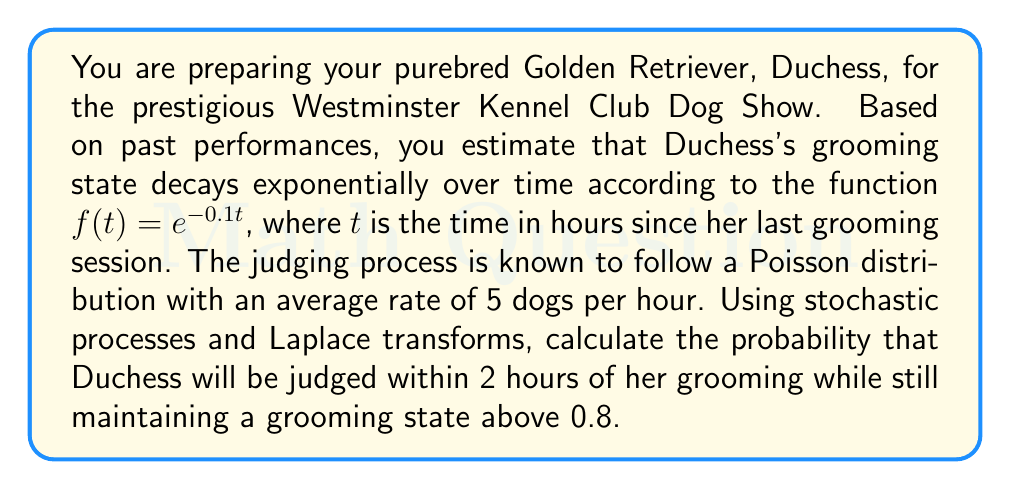Give your solution to this math problem. To solve this problem, we'll use stochastic processes and Laplace transforms. Let's break it down step by step:

1) First, we need to find the probability that Duchess's grooming state remains above 0.8 after 2 hours:

   $P(f(t) > 0.8) = P(e^{-0.1t} > 0.8)$
   $= P(t < -\ln(0.8)/0.1) \approx P(t < 2.23)$

2) Now, we need to find the probability that Duchess will be judged within 2 hours. This follows a Poisson distribution with rate $\lambda = 5$ dogs/hour.

   The probability of being judged within 2 hours is the complement of the probability of not being judged in 2 hours:

   $P(\text{judged in 2 hours}) = 1 - P(\text{not judged in 2 hours})$
   $= 1 - e^{-\lambda t}$
   $= 1 - e^{-5 \cdot 2} \approx 0.9999$

3) To combine these probabilities, we need to use the Laplace transform. The Laplace transform of the exponential decay function is:

   $\mathcal{L}\{e^{-0.1t}\} = \frac{1}{s + 0.1}$

4) The Laplace transform of the Poisson process (time until first event) is:

   $\mathcal{L}\{\lambda e^{-\lambda t}\} = \frac{\lambda}{s + \lambda}$

5) To find the probability of both events occurring (being judged within 2 hours while grooming state is above 0.8), we multiply these transforms:

   $\frac{1}{s + 0.1} \cdot \frac{5}{s + 5}$

6) To get the probability, we need to inverse Laplace transform this product and evaluate at t = 2:

   $\mathcal{L}^{-1}\{\frac{1}{s + 0.1} \cdot \frac{5}{s + 5}\} = \frac{5}{4.9}(e^{-0.1t} - e^{-5t})$

7) Evaluating at t = 2:

   $\frac{5}{4.9}(e^{-0.1 \cdot 2} - e^{-5 \cdot 2}) \approx 0.7769$

Therefore, the probability that Duchess will be judged within 2 hours of her grooming while still maintaining a grooming state above 0.8 is approximately 0.7769 or 77.69%.
Answer: The probability is approximately 0.7769 or 77.69%. 